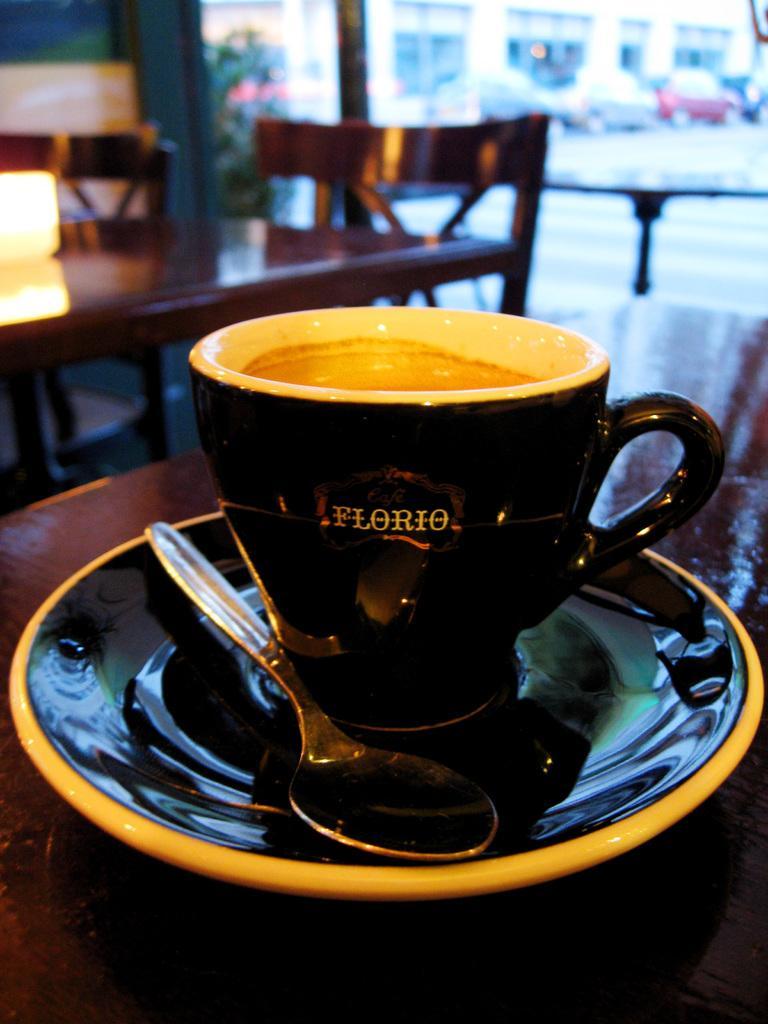Describe this image in one or two sentences. In this image there is a black color cup kept in a black color saucer ,there is a spoon in a table and in back ground there are chairs, car, building , plant ,light. 